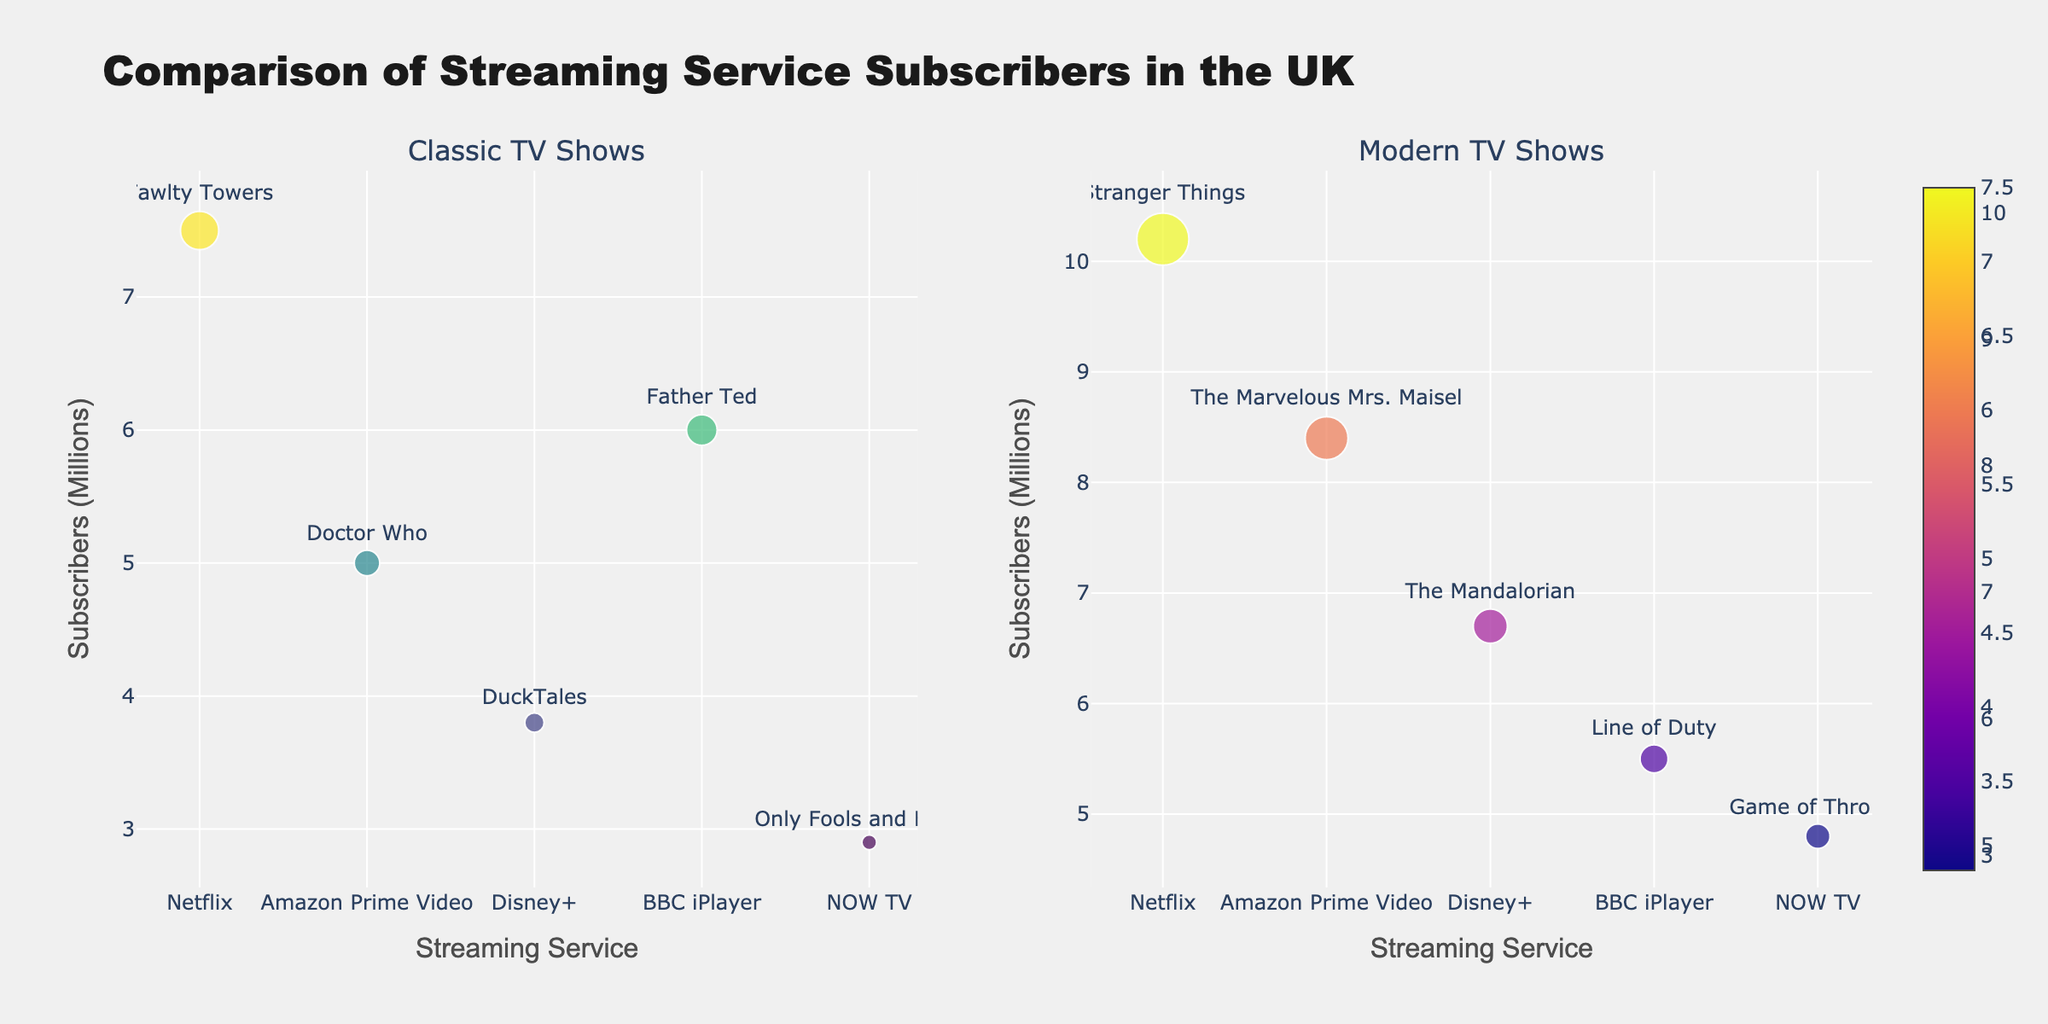What is the title of the figure? The title is usually at the top of the figure and is clearly labeled to describe the content of the plot.
Answer: Comparison of Streaming Service Subscribers in the UK Which streaming service has the highest number of subscribers for modern TV shows? By looking at the subplot for modern TV shows, find the data point with the highest y-value (subscribers). The highest y-value is for Netflix.
Answer: Netflix Which streaming service has the lowest number of subscribers for classic TV shows? By observing the subplot for classic TV shows, locate the data point with the lowest y-value (subscribers). The lowest y-value is for NOW TV.
Answer: NOW TV What is the total number of subscribers for classic TV shows and modern TV shows combined for Netflix? Add the number of subscribers from Netflix for classic and modern TV shows: 7.5 million + 10.2 million.
Answer: 17.7 million Which streaming services have more subscribers for modern TV shows than for classic TV shows? Compare the y-values for classic and modern TV shows for each streaming service. The services with higher values for modern TV shows are: Netflix, Amazon Prime Video, Disney+, and NOW TV.
Answer: Netflix, Amazon Prime Video, Disney+, NOW TV How does the number of subscribers for BBC iPlayer's classic TV shows compare to its modern TV shows? Look at the data points for BBC iPlayer in both subplots. The y-value for classic TV shows is 6.0 million, and for modern TV shows, it is 5.5 million.
Answer: BBC iPlayer has more subscribers for classic TV shows How many streaming services are represented in the figure? Count the unique streaming services displayed along the x-axis in either of the subplots. There are five unique streaming services: Netflix, Amazon Prime Video, Disney+, BBC iPlayer, and NOW TV.
Answer: Five Which streaming service has the closest number of subscribers for classic and modern TV shows? Find the difference between subscribers for classic and modern TV shows for each service and identify the smallest difference. BBC iPlayer has a difference of 0.5 million (6.0 million - 5.5 million).
Answer: BBC iPlayer What is the average number of subscribers for classic TV shows across all streaming services? Add the subscriber numbers for classic TV shows and divide by the total number of services (5). (7.5 + 5.0 + 3.8 + 6.0 + 2.9) / 5 = 25.2 / 5 = 5.04 million.
Answer: 5.04 million Which TV show examples are annotated for Netflix in both subplots? Refer to the text annotations for Netflix in both subplots. The classic TV show is "Fawlty Towers" and the modern TV show is "Stranger Things".
Answer: Fawlty Towers, Stranger Things 